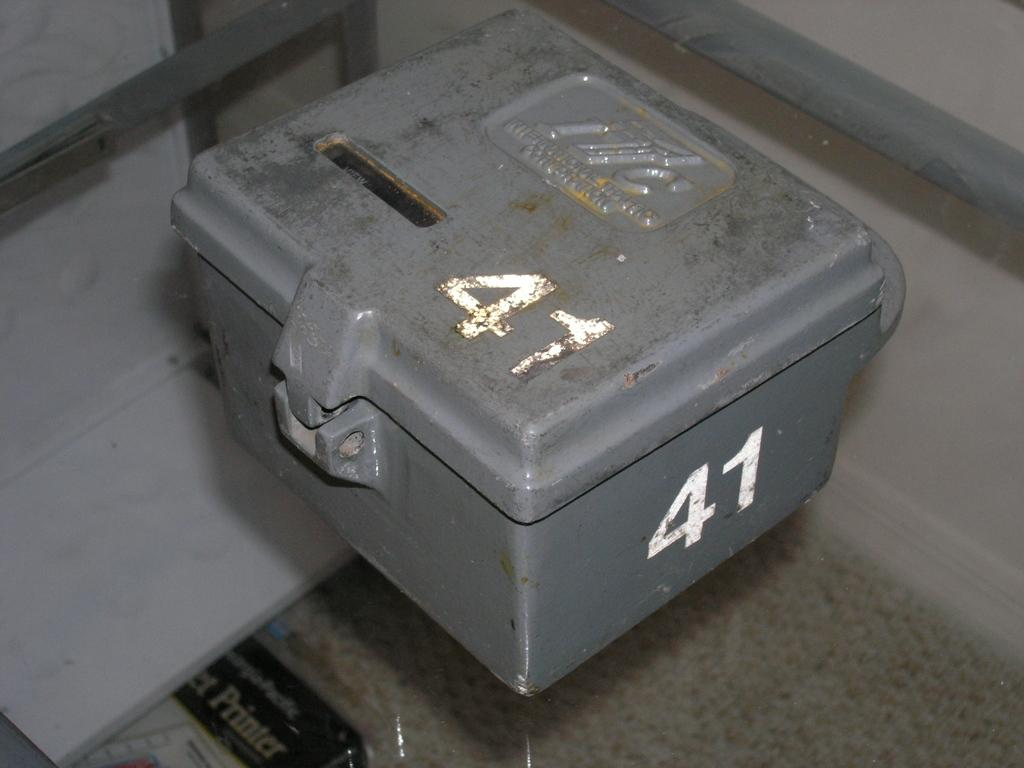<image>
Render a clear and concise summary of the photo. A grey industrial box with the number 41 on it that has a small hole to put things into it. 